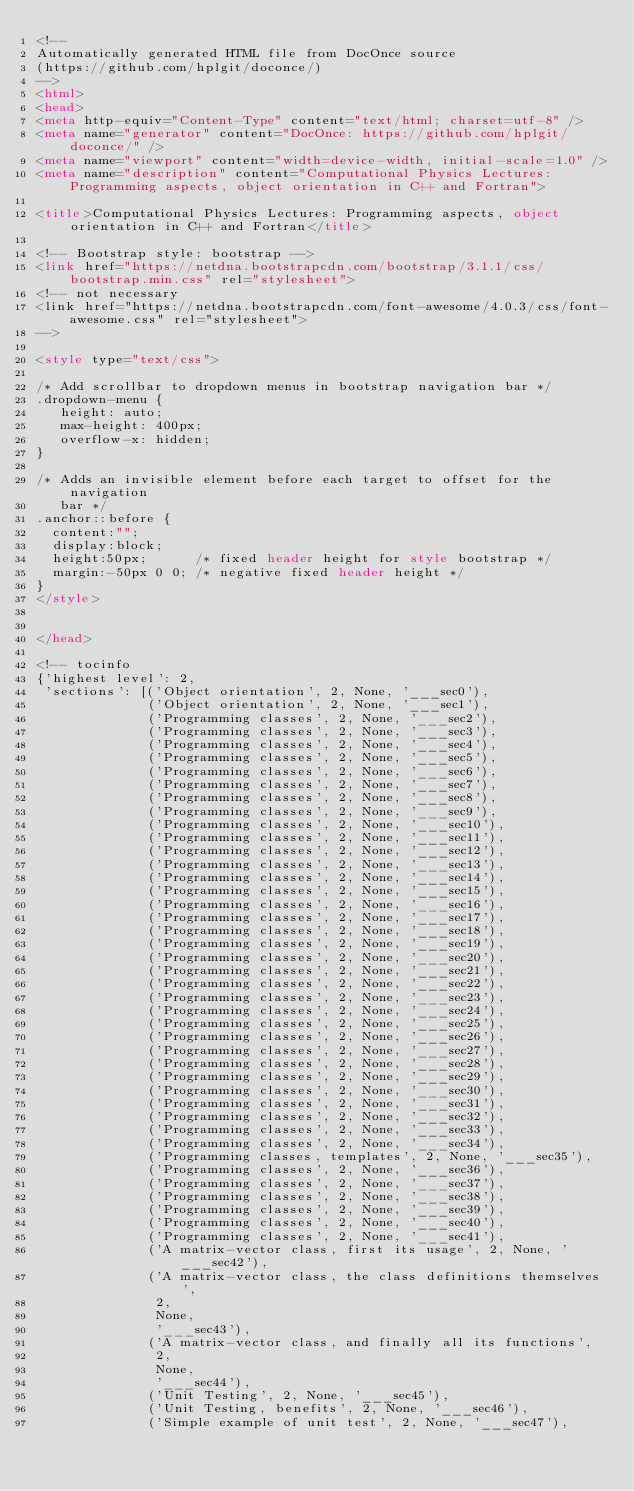<code> <loc_0><loc_0><loc_500><loc_500><_HTML_><!--
Automatically generated HTML file from DocOnce source
(https://github.com/hplgit/doconce/)
-->
<html>
<head>
<meta http-equiv="Content-Type" content="text/html; charset=utf-8" />
<meta name="generator" content="DocOnce: https://github.com/hplgit/doconce/" />
<meta name="viewport" content="width=device-width, initial-scale=1.0" />
<meta name="description" content="Computational Physics Lectures: Programming aspects, object orientation in C++ and Fortran">

<title>Computational Physics Lectures: Programming aspects, object orientation in C++ and Fortran</title>

<!-- Bootstrap style: bootstrap -->
<link href="https://netdna.bootstrapcdn.com/bootstrap/3.1.1/css/bootstrap.min.css" rel="stylesheet">
<!-- not necessary
<link href="https://netdna.bootstrapcdn.com/font-awesome/4.0.3/css/font-awesome.css" rel="stylesheet">
-->

<style type="text/css">

/* Add scrollbar to dropdown menus in bootstrap navigation bar */
.dropdown-menu {
   height: auto;
   max-height: 400px;
   overflow-x: hidden;
}

/* Adds an invisible element before each target to offset for the navigation
   bar */
.anchor::before {
  content:"";
  display:block;
  height:50px;      /* fixed header height for style bootstrap */
  margin:-50px 0 0; /* negative fixed header height */
}
</style>


</head>

<!-- tocinfo
{'highest level': 2,
 'sections': [('Object orientation', 2, None, '___sec0'),
              ('Object orientation', 2, None, '___sec1'),
              ('Programming classes', 2, None, '___sec2'),
              ('Programming classes', 2, None, '___sec3'),
              ('Programming classes', 2, None, '___sec4'),
              ('Programming classes', 2, None, '___sec5'),
              ('Programming classes', 2, None, '___sec6'),
              ('Programming classes', 2, None, '___sec7'),
              ('Programming classes', 2, None, '___sec8'),
              ('Programming classes', 2, None, '___sec9'),
              ('Programming classes', 2, None, '___sec10'),
              ('Programming classes', 2, None, '___sec11'),
              ('Programming classes', 2, None, '___sec12'),
              ('Programming classes', 2, None, '___sec13'),
              ('Programming classes', 2, None, '___sec14'),
              ('Programming classes', 2, None, '___sec15'),
              ('Programming classes', 2, None, '___sec16'),
              ('Programming classes', 2, None, '___sec17'),
              ('Programming classes', 2, None, '___sec18'),
              ('Programming classes', 2, None, '___sec19'),
              ('Programming classes', 2, None, '___sec20'),
              ('Programming classes', 2, None, '___sec21'),
              ('Programming classes', 2, None, '___sec22'),
              ('Programming classes', 2, None, '___sec23'),
              ('Programming classes', 2, None, '___sec24'),
              ('Programming classes', 2, None, '___sec25'),
              ('Programming classes', 2, None, '___sec26'),
              ('Programming classes', 2, None, '___sec27'),
              ('Programming classes', 2, None, '___sec28'),
              ('Programming classes', 2, None, '___sec29'),
              ('Programming classes', 2, None, '___sec30'),
              ('Programming classes', 2, None, '___sec31'),
              ('Programming classes', 2, None, '___sec32'),
              ('Programming classes', 2, None, '___sec33'),
              ('Programming classes', 2, None, '___sec34'),
              ('Programming classes, templates', 2, None, '___sec35'),
              ('Programming classes', 2, None, '___sec36'),
              ('Programming classes', 2, None, '___sec37'),
              ('Programming classes', 2, None, '___sec38'),
              ('Programming classes', 2, None, '___sec39'),
              ('Programming classes', 2, None, '___sec40'),
              ('Programming classes', 2, None, '___sec41'),
              ('A matrix-vector class, first its usage', 2, None, '___sec42'),
              ('A matrix-vector class, the class definitions themselves',
               2,
               None,
               '___sec43'),
              ('A matrix-vector class, and finally all its functions',
               2,
               None,
               '___sec44'),
              ('Unit Testing', 2, None, '___sec45'),
              ('Unit Testing, benefits', 2, None, '___sec46'),
              ('Simple example of unit test', 2, None, '___sec47'),</code> 